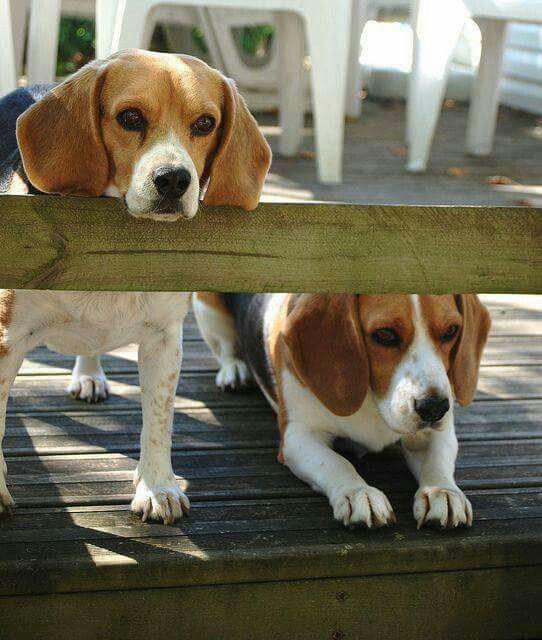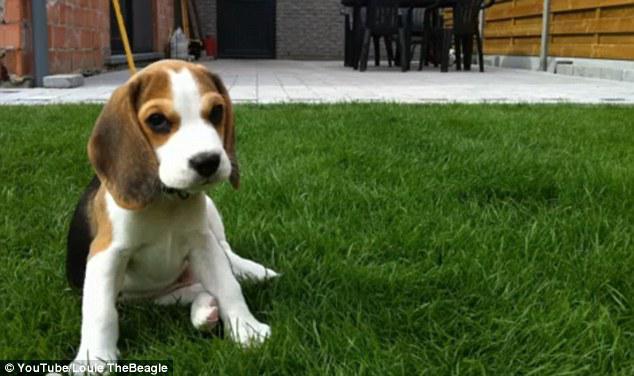The first image is the image on the left, the second image is the image on the right. Analyze the images presented: Is the assertion "An image shows beagle dogs behind a horizontal wood plank rail." valid? Answer yes or no. Yes. 